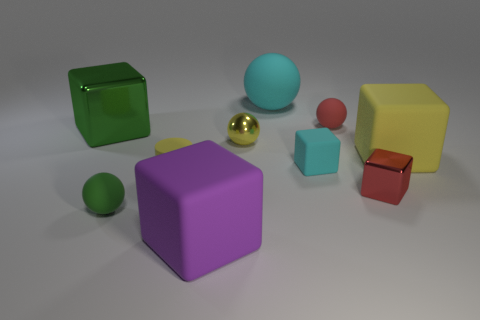What could be the purpose of these objects and the setting they are placed in? The objects in the image resemble children's blocks and balls, typically used for play and educational purposes. The setting, with a neutral background and evenly-spaced objects, could suggest a staged environment, perhaps for a photoshoot, classroom activity, or a display. The variety in color and size might be designed to stimulate visual and spatial learning, or simply to provide amusement through building and arranging. It could also be a setup for testing physical properties like balance, geometry, or color theory, possibly in an academic or design context. 